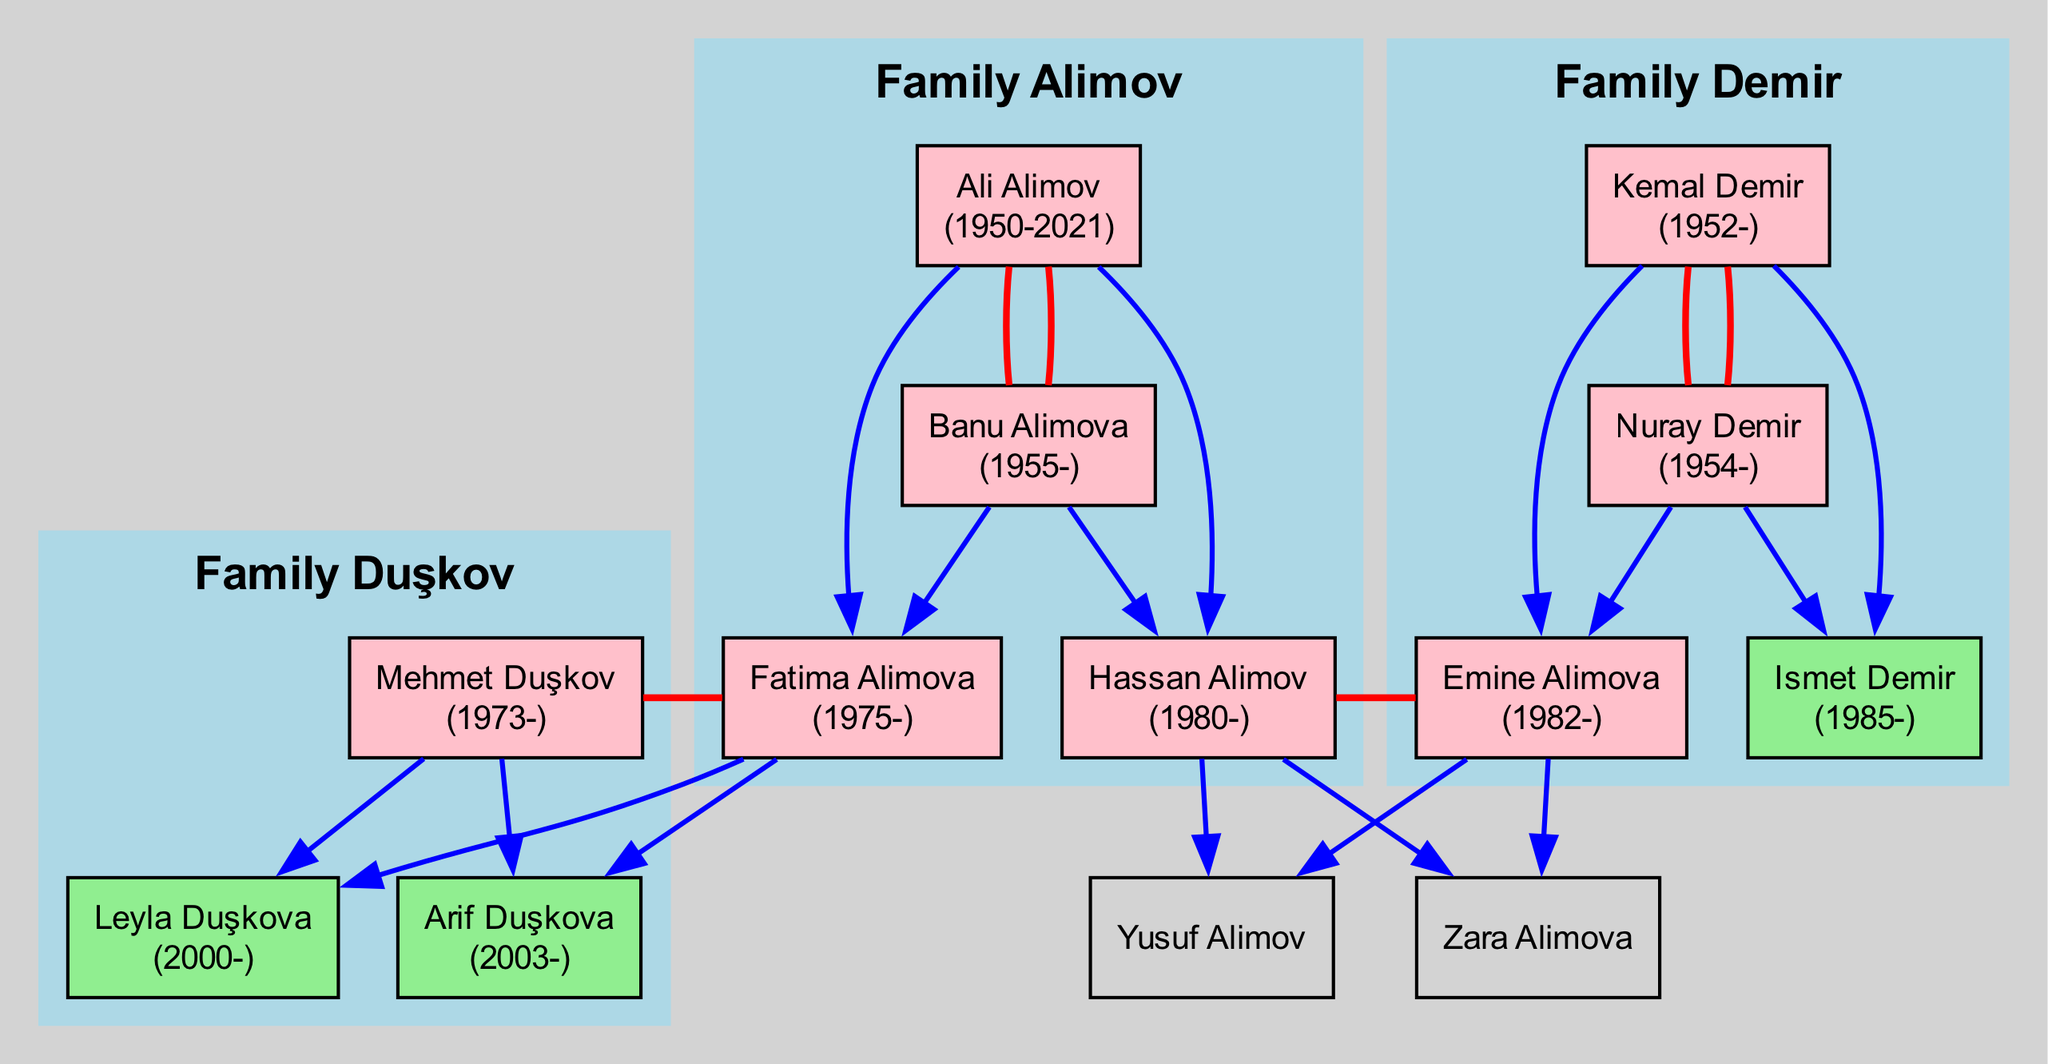What is the birth year of Ali Alimov? By examining the nodes related to the Alimov family, Ali Alimov’s node states his birth year, which is 1950.
Answer: 1950 How many children does Banu Alimova have? Looking at Banu Alimova’s node, it lists her children as Fatima Alimova and Hassan Alimov, totaling two children.
Answer: 2 Who is the spouse of Emine Alimova? The diagram shows a connection between Emine Alimova and her spouse, which is Hassan Alimov.
Answer: Hassan Alimov Which family does Leyla Duşkova belong to? The node for Leyla Duşkova indicates she is a member of the Duşkov family, as marked in the subgraph for Family Duşkov.
Answer: Family Duşkov How many members are in Family Demir? Counting the nodes within the Family Demir subgraph, there are four members: Kemal Demir, Nuray Demir, Emine Alimova, and Ismet Demir.
Answer: 4 What is the relationship between Fatima Alimova and Mehmet Duşkov? The diagram shows that Fatima Alimova is married to Mehmet Duşkov, indicating they are spouses.
Answer: Spouses Which grandchildren does Ali Alimov have? By tracing the children of Ali Alimov, we find that his daughter Fatima has Leyla Duşkova and Arif Duşkova as children, and his son Hassan has Zara Alimova and Yusuf Alimov, totaling four grandchildren.
Answer: Leyla Duşkova, Arif Duşkova, Zara Alimova, Yusuf Alimov What is the birth year of Kemal Demir? The node for Kemal Demir within the Family Demir subgraph clearly shows his birth year as 1952.
Answer: 1952 Who is the only child of Mehmet Duşkov? Looking closely at Mehmet Duşkov’s node, it indicates he has two children: Leyla Duşkova and Arif Duşkova, so he does not have an only child. This question is misleading; he has two children.
Answer: 2 